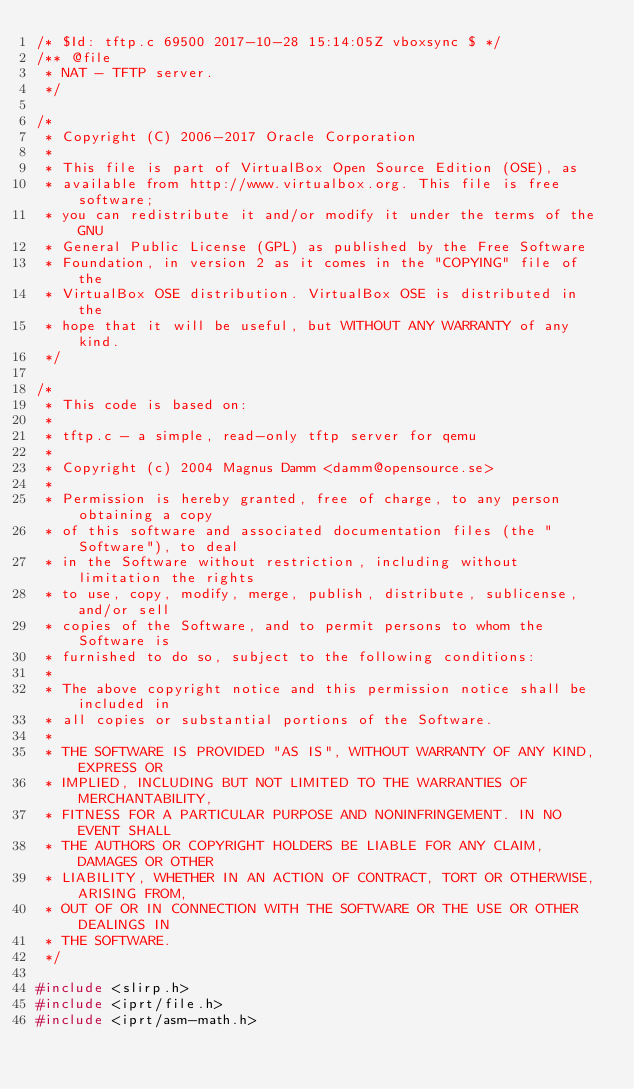<code> <loc_0><loc_0><loc_500><loc_500><_C_>/* $Id: tftp.c 69500 2017-10-28 15:14:05Z vboxsync $ */
/** @file
 * NAT - TFTP server.
 */

/*
 * Copyright (C) 2006-2017 Oracle Corporation
 *
 * This file is part of VirtualBox Open Source Edition (OSE), as
 * available from http://www.virtualbox.org. This file is free software;
 * you can redistribute it and/or modify it under the terms of the GNU
 * General Public License (GPL) as published by the Free Software
 * Foundation, in version 2 as it comes in the "COPYING" file of the
 * VirtualBox OSE distribution. VirtualBox OSE is distributed in the
 * hope that it will be useful, but WITHOUT ANY WARRANTY of any kind.
 */

/*
 * This code is based on:
 *
 * tftp.c - a simple, read-only tftp server for qemu
 *
 * Copyright (c) 2004 Magnus Damm <damm@opensource.se>
 *
 * Permission is hereby granted, free of charge, to any person obtaining a copy
 * of this software and associated documentation files (the "Software"), to deal
 * in the Software without restriction, including without limitation the rights
 * to use, copy, modify, merge, publish, distribute, sublicense, and/or sell
 * copies of the Software, and to permit persons to whom the Software is
 * furnished to do so, subject to the following conditions:
 *
 * The above copyright notice and this permission notice shall be included in
 * all copies or substantial portions of the Software.
 *
 * THE SOFTWARE IS PROVIDED "AS IS", WITHOUT WARRANTY OF ANY KIND, EXPRESS OR
 * IMPLIED, INCLUDING BUT NOT LIMITED TO THE WARRANTIES OF MERCHANTABILITY,
 * FITNESS FOR A PARTICULAR PURPOSE AND NONINFRINGEMENT. IN NO EVENT SHALL
 * THE AUTHORS OR COPYRIGHT HOLDERS BE LIABLE FOR ANY CLAIM, DAMAGES OR OTHER
 * LIABILITY, WHETHER IN AN ACTION OF CONTRACT, TORT OR OTHERWISE, ARISING FROM,
 * OUT OF OR IN CONNECTION WITH THE SOFTWARE OR THE USE OR OTHER DEALINGS IN
 * THE SOFTWARE.
 */

#include <slirp.h>
#include <iprt/file.h>
#include <iprt/asm-math.h>
</code> 